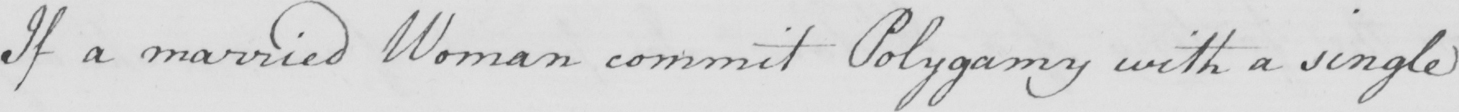What does this handwritten line say? If a married Woman commit Polygamy with a single 